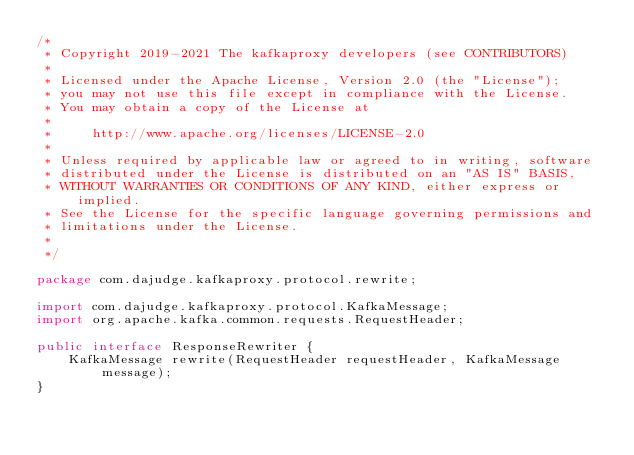Convert code to text. <code><loc_0><loc_0><loc_500><loc_500><_Java_>/*
 * Copyright 2019-2021 The kafkaproxy developers (see CONTRIBUTORS)
 *
 * Licensed under the Apache License, Version 2.0 (the "License");
 * you may not use this file except in compliance with the License.
 * You may obtain a copy of the License at
 *
 *     http://www.apache.org/licenses/LICENSE-2.0
 *
 * Unless required by applicable law or agreed to in writing, software
 * distributed under the License is distributed on an "AS IS" BASIS,
 * WITHOUT WARRANTIES OR CONDITIONS OF ANY KIND, either express or implied.
 * See the License for the specific language governing permissions and
 * limitations under the License.
 *
 */

package com.dajudge.kafkaproxy.protocol.rewrite;

import com.dajudge.kafkaproxy.protocol.KafkaMessage;
import org.apache.kafka.common.requests.RequestHeader;

public interface ResponseRewriter {
    KafkaMessage rewrite(RequestHeader requestHeader, KafkaMessage message);
}
</code> 